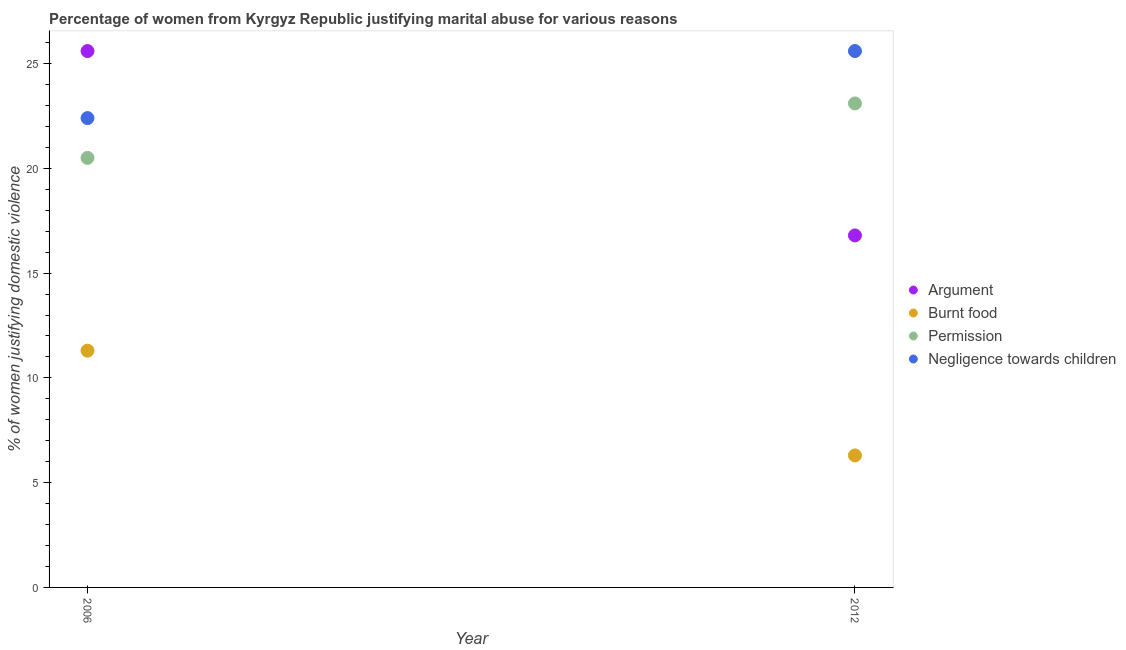How many different coloured dotlines are there?
Make the answer very short. 4. What is the percentage of women justifying abuse for burning food in 2006?
Offer a terse response. 11.3. Across all years, what is the maximum percentage of women justifying abuse for showing negligence towards children?
Ensure brevity in your answer.  25.6. Across all years, what is the minimum percentage of women justifying abuse for going without permission?
Give a very brief answer. 20.5. In which year was the percentage of women justifying abuse in the case of an argument minimum?
Offer a very short reply. 2012. What is the difference between the percentage of women justifying abuse for burning food in 2006 and that in 2012?
Give a very brief answer. 5. What is the average percentage of women justifying abuse for burning food per year?
Your answer should be compact. 8.8. In the year 2006, what is the difference between the percentage of women justifying abuse in the case of an argument and percentage of women justifying abuse for showing negligence towards children?
Give a very brief answer. 3.2. In how many years, is the percentage of women justifying abuse in the case of an argument greater than 21 %?
Provide a succinct answer. 1. What is the ratio of the percentage of women justifying abuse in the case of an argument in 2006 to that in 2012?
Ensure brevity in your answer.  1.52. Is the percentage of women justifying abuse in the case of an argument in 2006 less than that in 2012?
Ensure brevity in your answer.  No. Is it the case that in every year, the sum of the percentage of women justifying abuse in the case of an argument and percentage of women justifying abuse for burning food is greater than the percentage of women justifying abuse for going without permission?
Give a very brief answer. No. Are the values on the major ticks of Y-axis written in scientific E-notation?
Your response must be concise. No. Does the graph contain any zero values?
Keep it short and to the point. No. Does the graph contain grids?
Offer a terse response. No. Where does the legend appear in the graph?
Offer a very short reply. Center right. What is the title of the graph?
Ensure brevity in your answer.  Percentage of women from Kyrgyz Republic justifying marital abuse for various reasons. Does "Secondary" appear as one of the legend labels in the graph?
Your answer should be compact. No. What is the label or title of the Y-axis?
Your response must be concise. % of women justifying domestic violence. What is the % of women justifying domestic violence in Argument in 2006?
Offer a very short reply. 25.6. What is the % of women justifying domestic violence of Permission in 2006?
Keep it short and to the point. 20.5. What is the % of women justifying domestic violence in Negligence towards children in 2006?
Provide a succinct answer. 22.4. What is the % of women justifying domestic violence in Argument in 2012?
Ensure brevity in your answer.  16.8. What is the % of women justifying domestic violence in Permission in 2012?
Make the answer very short. 23.1. What is the % of women justifying domestic violence in Negligence towards children in 2012?
Your answer should be compact. 25.6. Across all years, what is the maximum % of women justifying domestic violence of Argument?
Your response must be concise. 25.6. Across all years, what is the maximum % of women justifying domestic violence in Burnt food?
Your response must be concise. 11.3. Across all years, what is the maximum % of women justifying domestic violence of Permission?
Offer a very short reply. 23.1. Across all years, what is the maximum % of women justifying domestic violence in Negligence towards children?
Ensure brevity in your answer.  25.6. Across all years, what is the minimum % of women justifying domestic violence of Burnt food?
Your response must be concise. 6.3. Across all years, what is the minimum % of women justifying domestic violence of Negligence towards children?
Offer a very short reply. 22.4. What is the total % of women justifying domestic violence in Argument in the graph?
Ensure brevity in your answer.  42.4. What is the total % of women justifying domestic violence of Permission in the graph?
Offer a terse response. 43.6. What is the total % of women justifying domestic violence in Negligence towards children in the graph?
Your answer should be compact. 48. What is the difference between the % of women justifying domestic violence of Argument in 2006 and that in 2012?
Your answer should be compact. 8.8. What is the difference between the % of women justifying domestic violence in Burnt food in 2006 and that in 2012?
Ensure brevity in your answer.  5. What is the difference between the % of women justifying domestic violence in Permission in 2006 and that in 2012?
Keep it short and to the point. -2.6. What is the difference between the % of women justifying domestic violence in Argument in 2006 and the % of women justifying domestic violence in Burnt food in 2012?
Give a very brief answer. 19.3. What is the difference between the % of women justifying domestic violence in Argument in 2006 and the % of women justifying domestic violence in Permission in 2012?
Ensure brevity in your answer.  2.5. What is the difference between the % of women justifying domestic violence of Argument in 2006 and the % of women justifying domestic violence of Negligence towards children in 2012?
Your response must be concise. 0. What is the difference between the % of women justifying domestic violence of Burnt food in 2006 and the % of women justifying domestic violence of Permission in 2012?
Ensure brevity in your answer.  -11.8. What is the difference between the % of women justifying domestic violence of Burnt food in 2006 and the % of women justifying domestic violence of Negligence towards children in 2012?
Offer a terse response. -14.3. What is the difference between the % of women justifying domestic violence in Permission in 2006 and the % of women justifying domestic violence in Negligence towards children in 2012?
Your response must be concise. -5.1. What is the average % of women justifying domestic violence of Argument per year?
Your answer should be compact. 21.2. What is the average % of women justifying domestic violence in Burnt food per year?
Provide a short and direct response. 8.8. What is the average % of women justifying domestic violence in Permission per year?
Offer a terse response. 21.8. In the year 2006, what is the difference between the % of women justifying domestic violence of Argument and % of women justifying domestic violence of Negligence towards children?
Your answer should be very brief. 3.2. In the year 2006, what is the difference between the % of women justifying domestic violence of Burnt food and % of women justifying domestic violence of Permission?
Offer a very short reply. -9.2. In the year 2006, what is the difference between the % of women justifying domestic violence of Burnt food and % of women justifying domestic violence of Negligence towards children?
Your answer should be compact. -11.1. In the year 2006, what is the difference between the % of women justifying domestic violence of Permission and % of women justifying domestic violence of Negligence towards children?
Your answer should be compact. -1.9. In the year 2012, what is the difference between the % of women justifying domestic violence of Argument and % of women justifying domestic violence of Negligence towards children?
Keep it short and to the point. -8.8. In the year 2012, what is the difference between the % of women justifying domestic violence in Burnt food and % of women justifying domestic violence in Permission?
Give a very brief answer. -16.8. In the year 2012, what is the difference between the % of women justifying domestic violence of Burnt food and % of women justifying domestic violence of Negligence towards children?
Your answer should be compact. -19.3. In the year 2012, what is the difference between the % of women justifying domestic violence of Permission and % of women justifying domestic violence of Negligence towards children?
Your answer should be compact. -2.5. What is the ratio of the % of women justifying domestic violence in Argument in 2006 to that in 2012?
Provide a short and direct response. 1.52. What is the ratio of the % of women justifying domestic violence of Burnt food in 2006 to that in 2012?
Offer a terse response. 1.79. What is the ratio of the % of women justifying domestic violence in Permission in 2006 to that in 2012?
Keep it short and to the point. 0.89. What is the difference between the highest and the second highest % of women justifying domestic violence of Argument?
Provide a short and direct response. 8.8. What is the difference between the highest and the second highest % of women justifying domestic violence in Burnt food?
Keep it short and to the point. 5. What is the difference between the highest and the second highest % of women justifying domestic violence of Negligence towards children?
Your answer should be compact. 3.2. What is the difference between the highest and the lowest % of women justifying domestic violence in Burnt food?
Your answer should be compact. 5. 